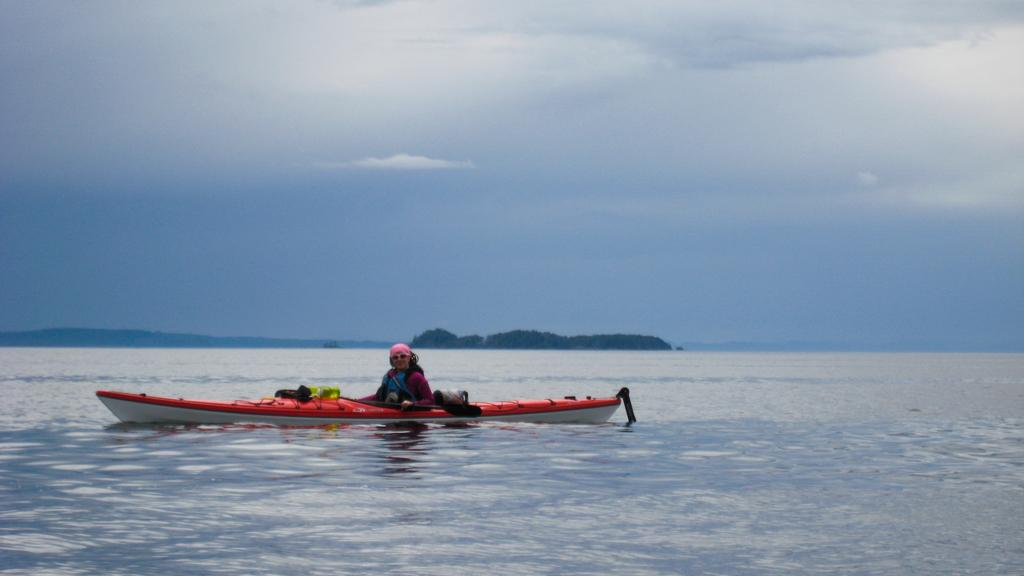What is the main object in the middle of the picture? There is a sea kayak in the middle of the picture. Who is in the sea kayak? There is a person in the sea kayak. What can be seen in the background of the picture? There is an ocean and the sky visible in the background of the picture. What type of juice is the person in the sea kayak drinking in the image? There is no juice present in the image, as it features a person in a sea kayak with an ocean and sky in the background. 